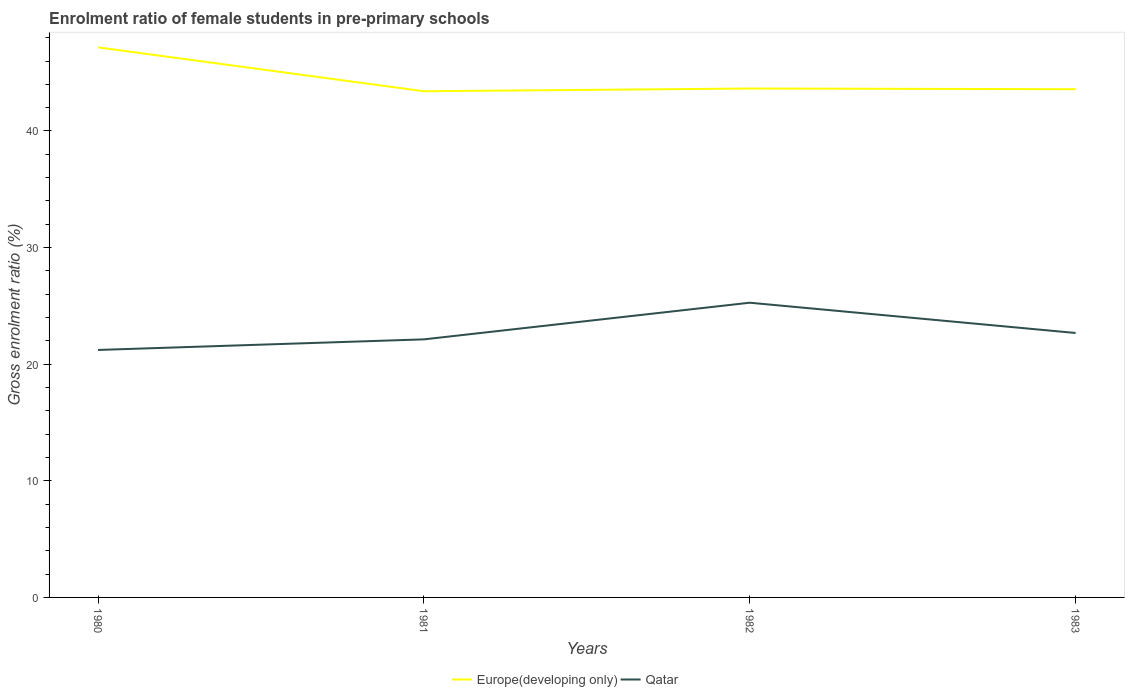How many different coloured lines are there?
Provide a short and direct response. 2. Does the line corresponding to Qatar intersect with the line corresponding to Europe(developing only)?
Provide a short and direct response. No. Is the number of lines equal to the number of legend labels?
Offer a terse response. Yes. Across all years, what is the maximum enrolment ratio of female students in pre-primary schools in Qatar?
Your answer should be very brief. 21.22. What is the total enrolment ratio of female students in pre-primary schools in Qatar in the graph?
Your answer should be very brief. -1.46. What is the difference between the highest and the second highest enrolment ratio of female students in pre-primary schools in Europe(developing only)?
Your response must be concise. 3.76. How many years are there in the graph?
Your answer should be very brief. 4. Are the values on the major ticks of Y-axis written in scientific E-notation?
Your answer should be compact. No. Does the graph contain grids?
Your response must be concise. No. Where does the legend appear in the graph?
Keep it short and to the point. Bottom center. How many legend labels are there?
Offer a very short reply. 2. How are the legend labels stacked?
Give a very brief answer. Horizontal. What is the title of the graph?
Ensure brevity in your answer.  Enrolment ratio of female students in pre-primary schools. What is the label or title of the X-axis?
Offer a terse response. Years. What is the Gross enrolment ratio (%) in Europe(developing only) in 1980?
Provide a short and direct response. 47.17. What is the Gross enrolment ratio (%) in Qatar in 1980?
Ensure brevity in your answer.  21.22. What is the Gross enrolment ratio (%) in Europe(developing only) in 1981?
Offer a very short reply. 43.41. What is the Gross enrolment ratio (%) of Qatar in 1981?
Give a very brief answer. 22.13. What is the Gross enrolment ratio (%) in Europe(developing only) in 1982?
Ensure brevity in your answer.  43.64. What is the Gross enrolment ratio (%) of Qatar in 1982?
Ensure brevity in your answer.  25.27. What is the Gross enrolment ratio (%) of Europe(developing only) in 1983?
Provide a short and direct response. 43.58. What is the Gross enrolment ratio (%) in Qatar in 1983?
Offer a terse response. 22.68. Across all years, what is the maximum Gross enrolment ratio (%) of Europe(developing only)?
Make the answer very short. 47.17. Across all years, what is the maximum Gross enrolment ratio (%) of Qatar?
Ensure brevity in your answer.  25.27. Across all years, what is the minimum Gross enrolment ratio (%) of Europe(developing only)?
Your response must be concise. 43.41. Across all years, what is the minimum Gross enrolment ratio (%) in Qatar?
Make the answer very short. 21.22. What is the total Gross enrolment ratio (%) of Europe(developing only) in the graph?
Keep it short and to the point. 177.8. What is the total Gross enrolment ratio (%) in Qatar in the graph?
Keep it short and to the point. 91.3. What is the difference between the Gross enrolment ratio (%) in Europe(developing only) in 1980 and that in 1981?
Offer a terse response. 3.76. What is the difference between the Gross enrolment ratio (%) of Qatar in 1980 and that in 1981?
Provide a succinct answer. -0.91. What is the difference between the Gross enrolment ratio (%) in Europe(developing only) in 1980 and that in 1982?
Offer a very short reply. 3.53. What is the difference between the Gross enrolment ratio (%) in Qatar in 1980 and that in 1982?
Ensure brevity in your answer.  -4.05. What is the difference between the Gross enrolment ratio (%) of Europe(developing only) in 1980 and that in 1983?
Offer a terse response. 3.59. What is the difference between the Gross enrolment ratio (%) of Qatar in 1980 and that in 1983?
Give a very brief answer. -1.46. What is the difference between the Gross enrolment ratio (%) in Europe(developing only) in 1981 and that in 1982?
Keep it short and to the point. -0.23. What is the difference between the Gross enrolment ratio (%) in Qatar in 1981 and that in 1982?
Your answer should be very brief. -3.14. What is the difference between the Gross enrolment ratio (%) of Europe(developing only) in 1981 and that in 1983?
Provide a short and direct response. -0.18. What is the difference between the Gross enrolment ratio (%) of Qatar in 1981 and that in 1983?
Your answer should be compact. -0.55. What is the difference between the Gross enrolment ratio (%) in Europe(developing only) in 1982 and that in 1983?
Give a very brief answer. 0.06. What is the difference between the Gross enrolment ratio (%) in Qatar in 1982 and that in 1983?
Your answer should be very brief. 2.6. What is the difference between the Gross enrolment ratio (%) of Europe(developing only) in 1980 and the Gross enrolment ratio (%) of Qatar in 1981?
Keep it short and to the point. 25.04. What is the difference between the Gross enrolment ratio (%) in Europe(developing only) in 1980 and the Gross enrolment ratio (%) in Qatar in 1982?
Provide a succinct answer. 21.9. What is the difference between the Gross enrolment ratio (%) of Europe(developing only) in 1980 and the Gross enrolment ratio (%) of Qatar in 1983?
Ensure brevity in your answer.  24.49. What is the difference between the Gross enrolment ratio (%) of Europe(developing only) in 1981 and the Gross enrolment ratio (%) of Qatar in 1982?
Offer a very short reply. 18.13. What is the difference between the Gross enrolment ratio (%) of Europe(developing only) in 1981 and the Gross enrolment ratio (%) of Qatar in 1983?
Provide a succinct answer. 20.73. What is the difference between the Gross enrolment ratio (%) of Europe(developing only) in 1982 and the Gross enrolment ratio (%) of Qatar in 1983?
Offer a terse response. 20.96. What is the average Gross enrolment ratio (%) in Europe(developing only) per year?
Keep it short and to the point. 44.45. What is the average Gross enrolment ratio (%) of Qatar per year?
Your response must be concise. 22.83. In the year 1980, what is the difference between the Gross enrolment ratio (%) of Europe(developing only) and Gross enrolment ratio (%) of Qatar?
Ensure brevity in your answer.  25.95. In the year 1981, what is the difference between the Gross enrolment ratio (%) in Europe(developing only) and Gross enrolment ratio (%) in Qatar?
Your answer should be very brief. 21.28. In the year 1982, what is the difference between the Gross enrolment ratio (%) of Europe(developing only) and Gross enrolment ratio (%) of Qatar?
Keep it short and to the point. 18.37. In the year 1983, what is the difference between the Gross enrolment ratio (%) of Europe(developing only) and Gross enrolment ratio (%) of Qatar?
Offer a terse response. 20.9. What is the ratio of the Gross enrolment ratio (%) in Europe(developing only) in 1980 to that in 1981?
Offer a terse response. 1.09. What is the ratio of the Gross enrolment ratio (%) in Europe(developing only) in 1980 to that in 1982?
Give a very brief answer. 1.08. What is the ratio of the Gross enrolment ratio (%) of Qatar in 1980 to that in 1982?
Your answer should be very brief. 0.84. What is the ratio of the Gross enrolment ratio (%) in Europe(developing only) in 1980 to that in 1983?
Give a very brief answer. 1.08. What is the ratio of the Gross enrolment ratio (%) in Qatar in 1980 to that in 1983?
Offer a very short reply. 0.94. What is the ratio of the Gross enrolment ratio (%) in Qatar in 1981 to that in 1982?
Your answer should be very brief. 0.88. What is the ratio of the Gross enrolment ratio (%) of Qatar in 1981 to that in 1983?
Provide a succinct answer. 0.98. What is the ratio of the Gross enrolment ratio (%) of Qatar in 1982 to that in 1983?
Offer a terse response. 1.11. What is the difference between the highest and the second highest Gross enrolment ratio (%) in Europe(developing only)?
Offer a terse response. 3.53. What is the difference between the highest and the second highest Gross enrolment ratio (%) in Qatar?
Make the answer very short. 2.6. What is the difference between the highest and the lowest Gross enrolment ratio (%) in Europe(developing only)?
Ensure brevity in your answer.  3.76. What is the difference between the highest and the lowest Gross enrolment ratio (%) in Qatar?
Offer a terse response. 4.05. 